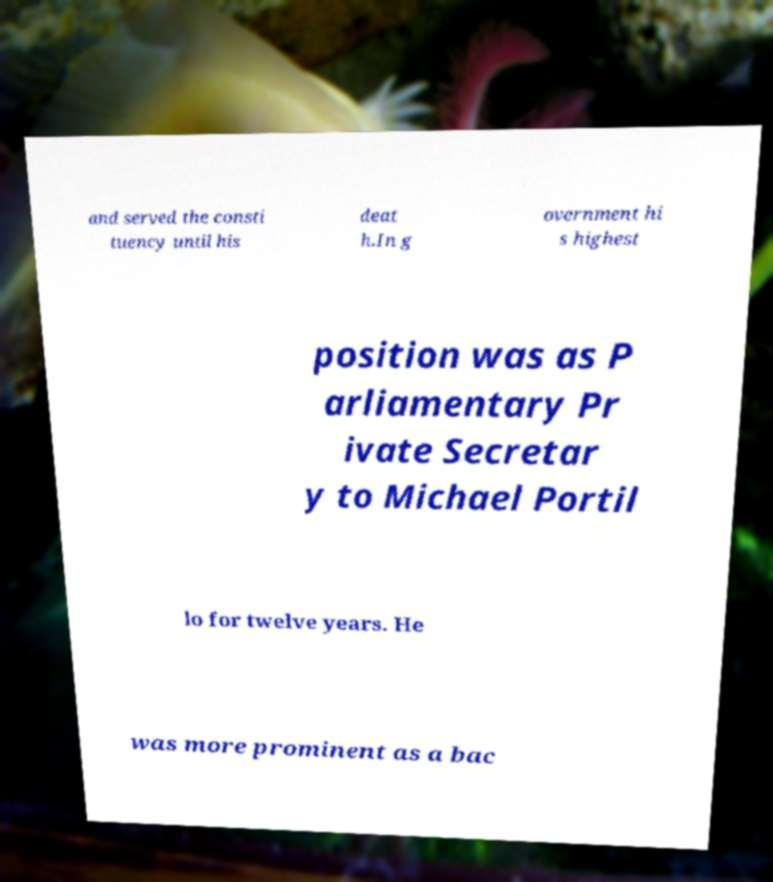Please identify and transcribe the text found in this image. and served the consti tuency until his deat h.In g overnment hi s highest position was as P arliamentary Pr ivate Secretar y to Michael Portil lo for twelve years. He was more prominent as a bac 